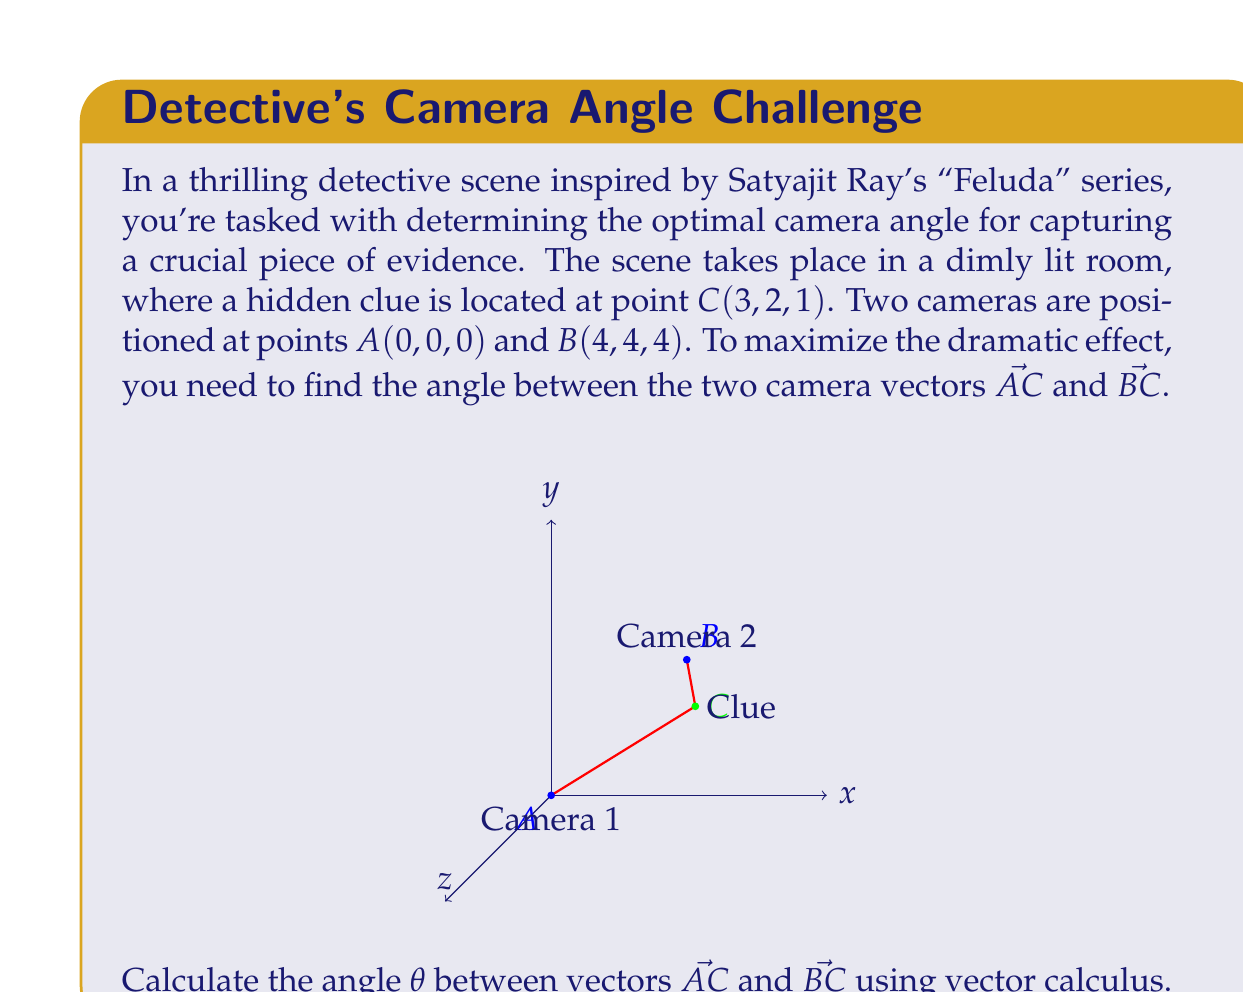Provide a solution to this math problem. To solve this problem, we'll follow these steps:

1) First, let's determine the vectors $\vec{AC}$ and $\vec{BC}$:
   $\vec{AC} = C - A = (3-0, 2-0, 1-0) = (3, 2, 1)$
   $\vec{BC} = C - B = (3-4, 2-4, 1-4) = (-1, -2, -3)$

2) The angle between two vectors can be calculated using the dot product formula:
   $$\cos \theta = \frac{\vec{AC} \cdot \vec{BC}}{|\vec{AC}||\vec{BC}|}$$

3) Let's calculate the dot product $\vec{AC} \cdot \vec{BC}$:
   $\vec{AC} \cdot \vec{BC} = (3)(-1) + (2)(-2) + (1)(-3) = -3 - 4 - 3 = -10$

4) Now, we need to calculate the magnitudes of $\vec{AC}$ and $\vec{BC}$:
   $|\vec{AC}| = \sqrt{3^2 + 2^2 + 1^2} = \sqrt{14}$
   $|\vec{BC}| = \sqrt{(-1)^2 + (-2)^2 + (-3)^2} = \sqrt{14}$

5) Substituting these values into the formula:
   $$\cos \theta = \frac{-10}{\sqrt{14} \cdot \sqrt{14}} = \frac{-10}{14} = -\frac{5}{7}$$

6) To find $\theta$, we need to take the inverse cosine (arccos) of both sides:
   $$\theta = \arccos(-\frac{5}{7})$$

7) Using a calculator or computer, we can determine that:
   $$\theta \approx 2.3180 \text{ radians} \approx 132.8493°$$

Therefore, the angle between the two camera vectors is approximately 132.85°.
Answer: $\theta = \arccos(-\frac{5}{7}) \approx 132.85°$ 